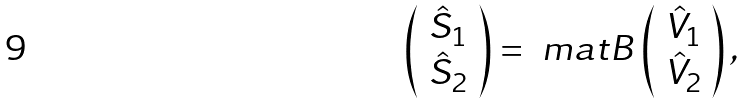Convert formula to latex. <formula><loc_0><loc_0><loc_500><loc_500>\left ( \begin{array} { c } \hat { S } _ { 1 } \\ \hat { S } _ { 2 } \end{array} \right ) = \ m a t { B } \left ( \begin{array} { c } \hat { V } _ { 1 } \\ \hat { V } _ { 2 } \end{array} \right ) ,</formula> 